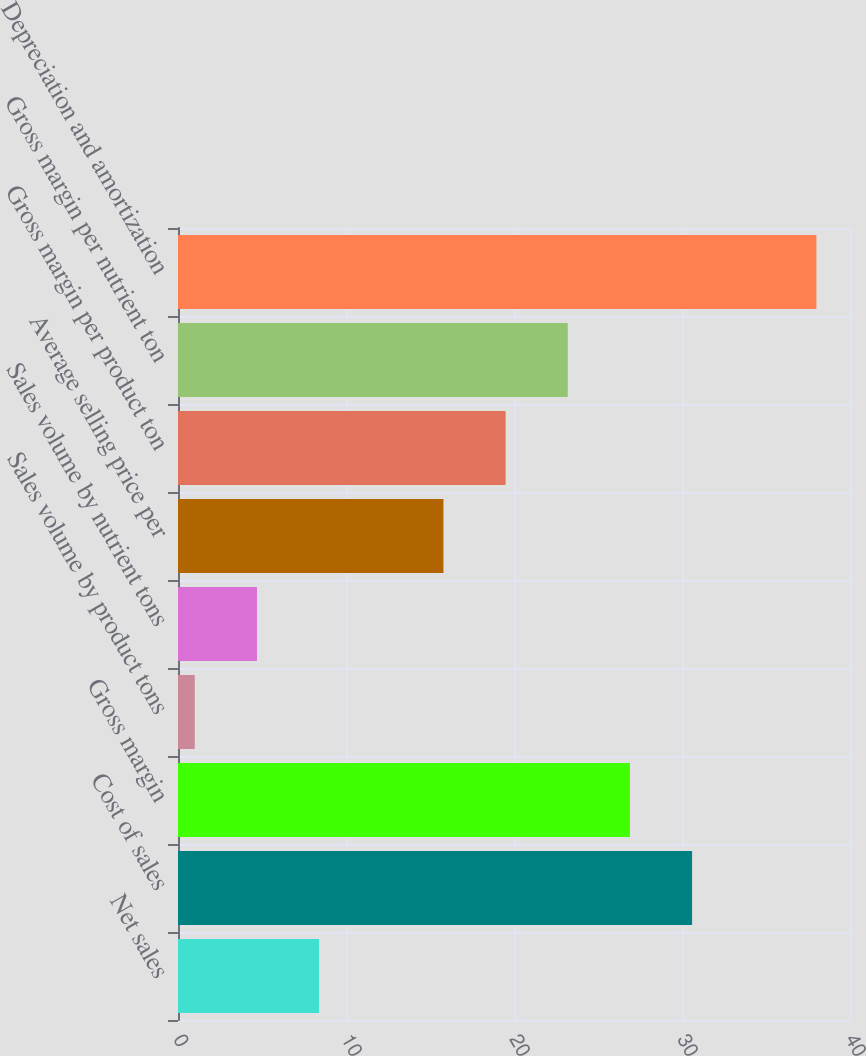<chart> <loc_0><loc_0><loc_500><loc_500><bar_chart><fcel>Net sales<fcel>Cost of sales<fcel>Gross margin<fcel>Sales volume by product tons<fcel>Sales volume by nutrient tons<fcel>Average selling price per<fcel>Gross margin per product ton<fcel>Gross margin per nutrient ton<fcel>Depreciation and amortization<nl><fcel>8.4<fcel>30.6<fcel>26.9<fcel>1<fcel>4.7<fcel>15.8<fcel>19.5<fcel>23.2<fcel>38<nl></chart> 